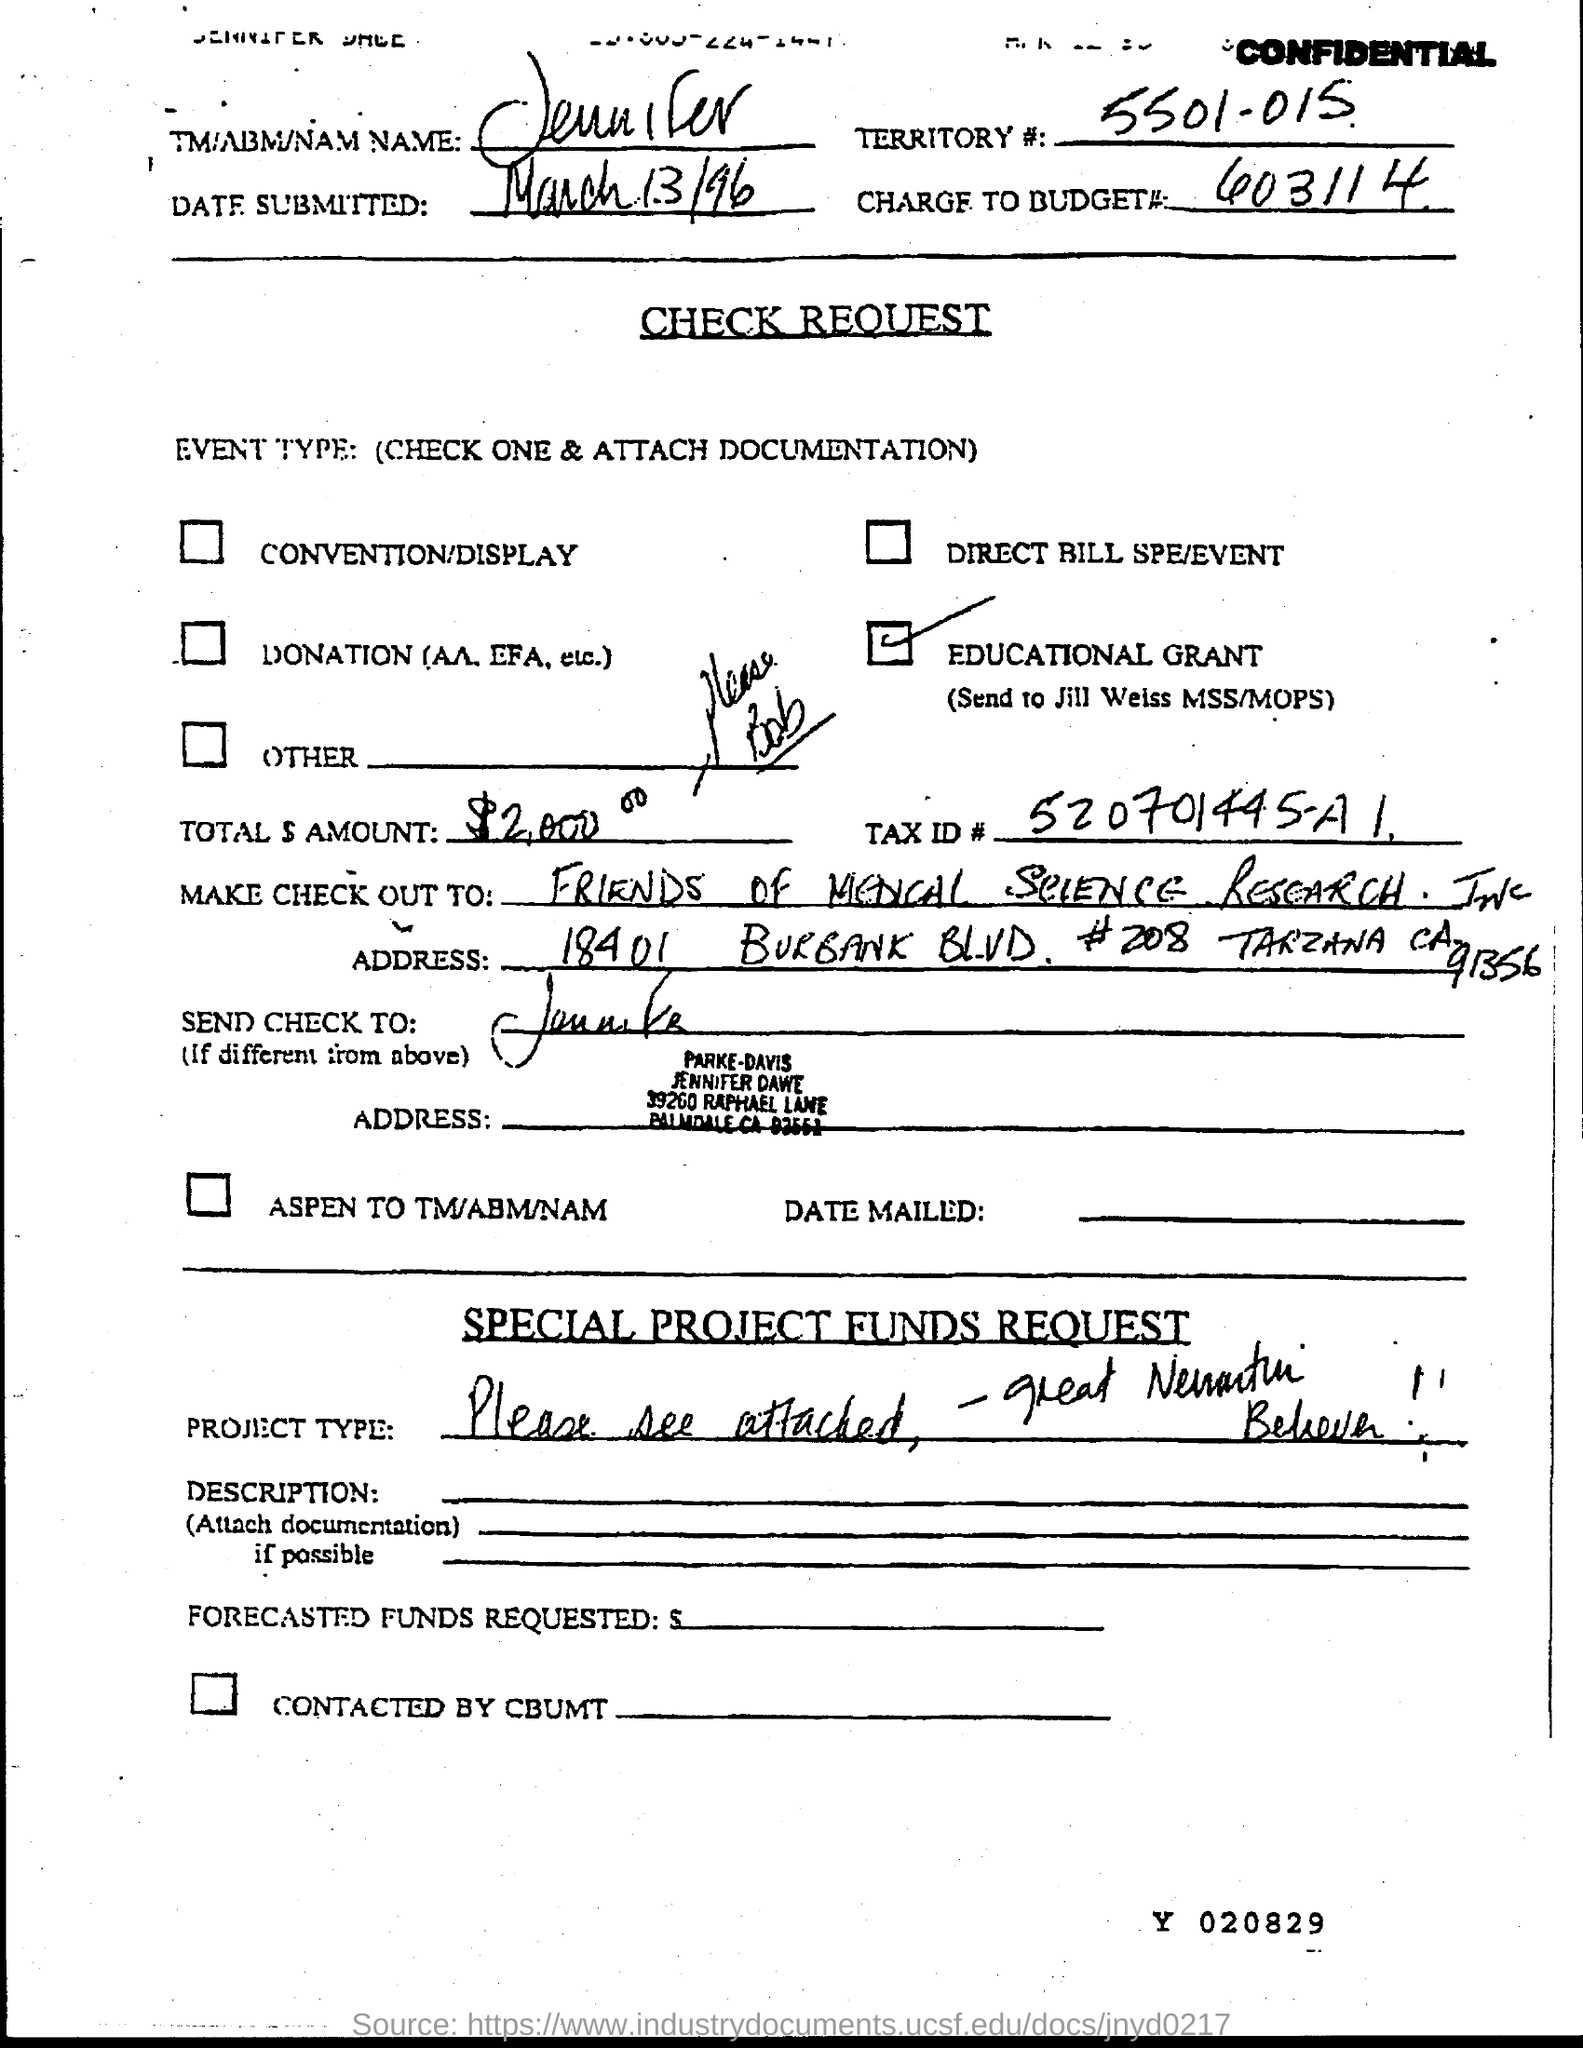Indicate a few pertinent items in this graphic. The date that is stated in the document is March 13th, 1996. The document provides the territory code as "5501-015. The Tax ID number mentioned in the check request is 520701445-A1. The charge to budget number 603114 is [insert numeric value]. The name given in the document is Jennifer. 